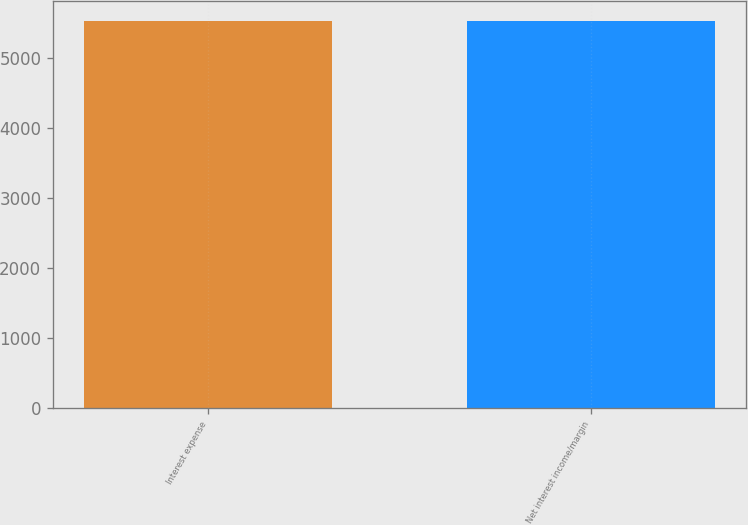Convert chart. <chart><loc_0><loc_0><loc_500><loc_500><bar_chart><fcel>Interest expense<fcel>Net interest income/margin<nl><fcel>5526<fcel>5526.1<nl></chart> 